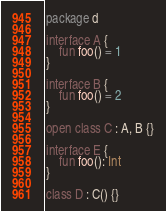<code> <loc_0><loc_0><loc_500><loc_500><_Kotlin_>package d

interface A {
    fun foo() = 1
}

interface B {
    fun foo() = 2
}

open class C : A, B {}

interface E {
    fun foo(): Int
}

class D : C() {}
</code> 